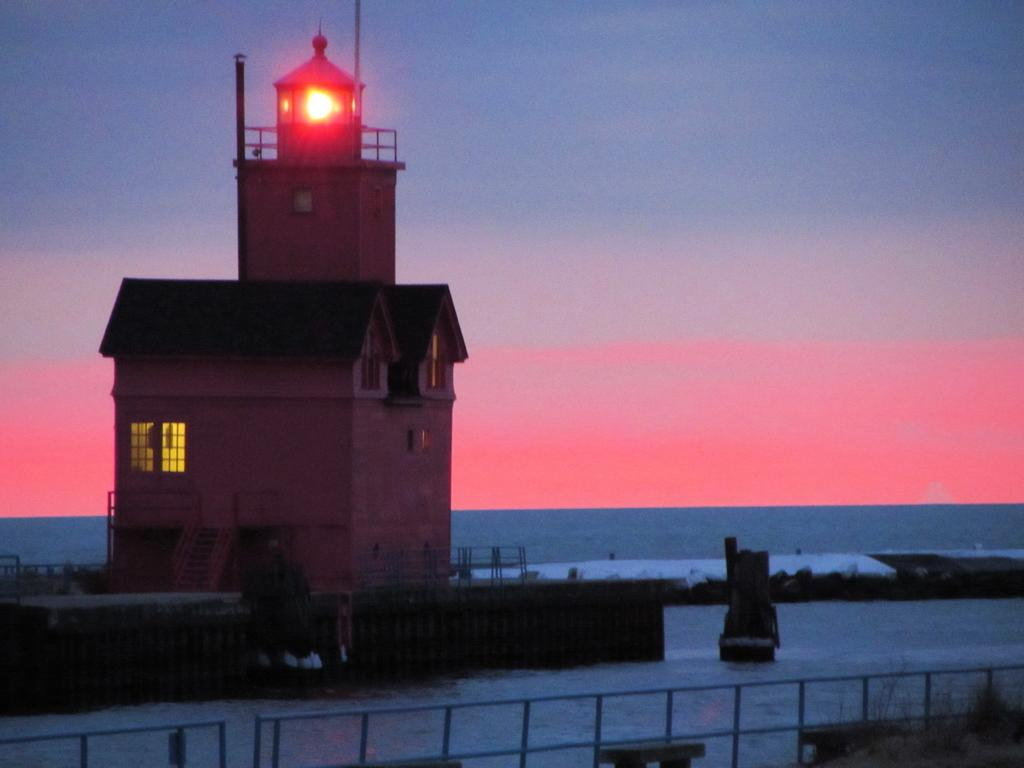What type of structure is visible in the image? There is a house in the image. What is the surrounding environment of the house? There is a water surface around the house. Where is the throne located in the image? There is no throne present in the image. What type of root can be seen growing near the house in the image? There is no root visible in the image; it only shows a house and a water surface around it. 